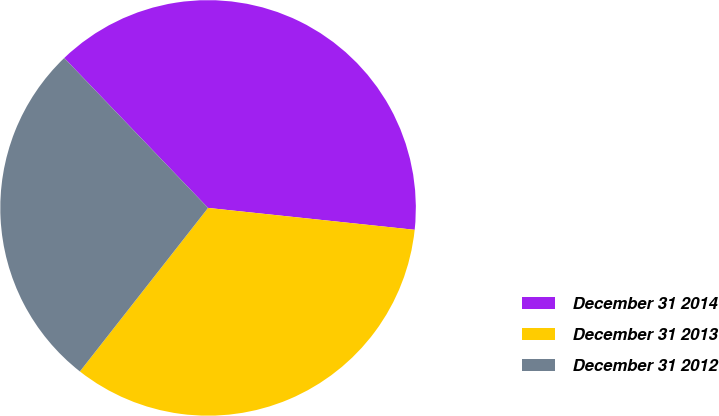Convert chart to OTSL. <chart><loc_0><loc_0><loc_500><loc_500><pie_chart><fcel>December 31 2014<fcel>December 31 2013<fcel>December 31 2012<nl><fcel>38.85%<fcel>33.9%<fcel>27.25%<nl></chart> 